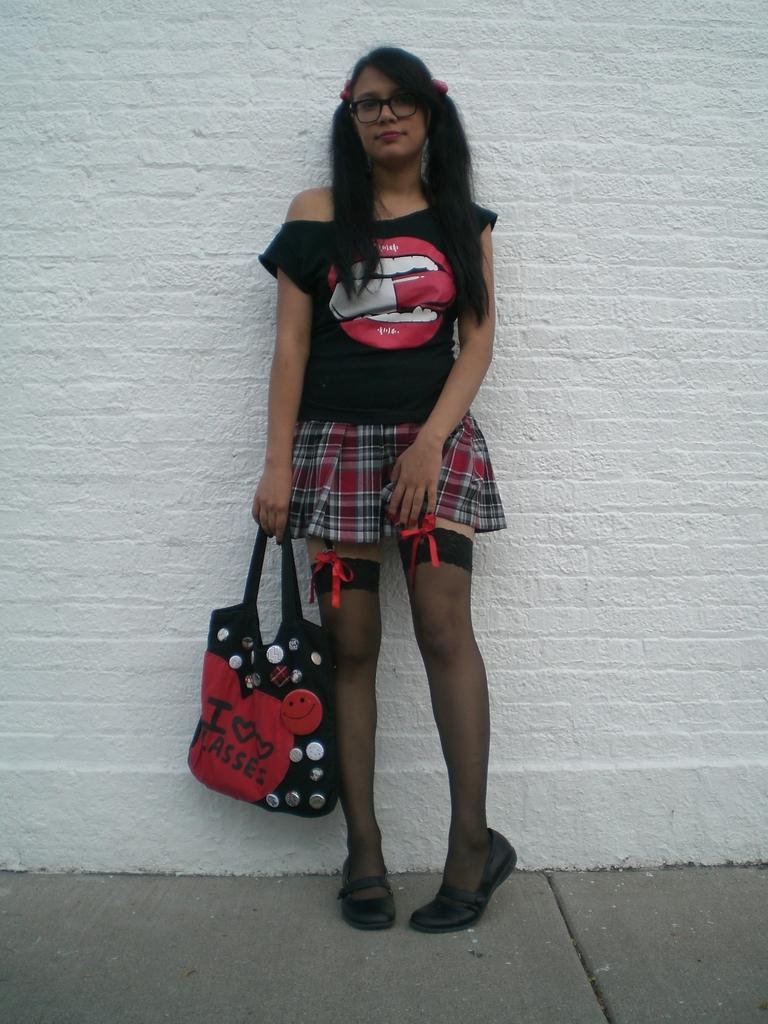How would you summarize this image in a sentence or two? In this image I can see a person standing and holding the bag. At the back there's a wall. 